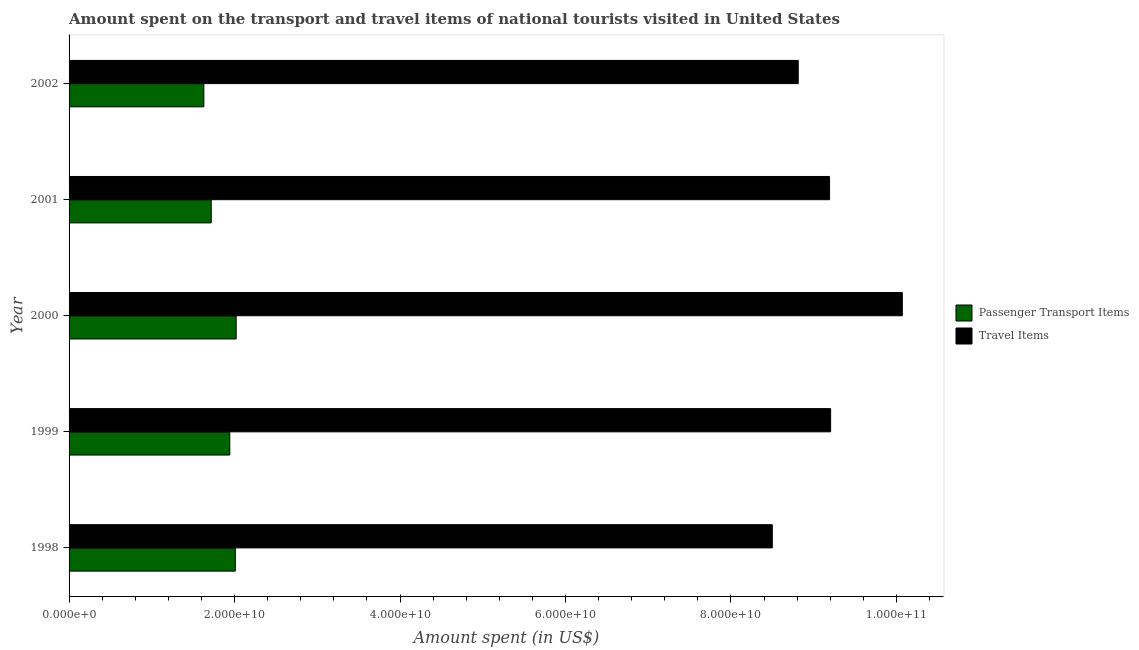How many bars are there on the 5th tick from the top?
Offer a terse response. 2. How many bars are there on the 3rd tick from the bottom?
Make the answer very short. 2. In how many cases, is the number of bars for a given year not equal to the number of legend labels?
Offer a very short reply. 0. What is the amount spent on passenger transport items in 2001?
Make the answer very short. 1.72e+1. Across all years, what is the maximum amount spent on passenger transport items?
Make the answer very short. 2.02e+1. Across all years, what is the minimum amount spent in travel items?
Ensure brevity in your answer.  8.50e+1. In which year was the amount spent in travel items minimum?
Offer a very short reply. 1998. What is the total amount spent on passenger transport items in the graph?
Your response must be concise. 9.32e+1. What is the difference between the amount spent on passenger transport items in 1999 and that in 2000?
Ensure brevity in your answer.  -7.71e+08. What is the difference between the amount spent in travel items in 2000 and the amount spent on passenger transport items in 2001?
Provide a succinct answer. 8.35e+1. What is the average amount spent in travel items per year?
Ensure brevity in your answer.  9.16e+1. In the year 2001, what is the difference between the amount spent in travel items and amount spent on passenger transport items?
Your response must be concise. 7.47e+1. In how many years, is the amount spent on passenger transport items greater than 64000000000 US$?
Your response must be concise. 0. What is the ratio of the amount spent on passenger transport items in 1998 to that in 2001?
Offer a very short reply. 1.17. What is the difference between the highest and the second highest amount spent in travel items?
Make the answer very short. 8.67e+09. What is the difference between the highest and the lowest amount spent in travel items?
Offer a terse response. 1.57e+1. Is the sum of the amount spent in travel items in 1998 and 1999 greater than the maximum amount spent on passenger transport items across all years?
Offer a terse response. Yes. What does the 1st bar from the top in 2000 represents?
Give a very brief answer. Travel Items. What does the 2nd bar from the bottom in 2001 represents?
Your answer should be very brief. Travel Items. Are all the bars in the graph horizontal?
Offer a terse response. Yes. Are the values on the major ticks of X-axis written in scientific E-notation?
Make the answer very short. Yes. Does the graph contain any zero values?
Keep it short and to the point. No. How many legend labels are there?
Ensure brevity in your answer.  2. What is the title of the graph?
Ensure brevity in your answer.  Amount spent on the transport and travel items of national tourists visited in United States. Does "Stunting" appear as one of the legend labels in the graph?
Your answer should be very brief. No. What is the label or title of the X-axis?
Ensure brevity in your answer.  Amount spent (in US$). What is the label or title of the Y-axis?
Ensure brevity in your answer.  Year. What is the Amount spent (in US$) in Passenger Transport Items in 1998?
Make the answer very short. 2.01e+1. What is the Amount spent (in US$) in Travel Items in 1998?
Make the answer very short. 8.50e+1. What is the Amount spent (in US$) of Passenger Transport Items in 1999?
Keep it short and to the point. 1.94e+1. What is the Amount spent (in US$) in Travel Items in 1999?
Provide a short and direct response. 9.20e+1. What is the Amount spent (in US$) of Passenger Transport Items in 2000?
Offer a terse response. 2.02e+1. What is the Amount spent (in US$) in Travel Items in 2000?
Keep it short and to the point. 1.01e+11. What is the Amount spent (in US$) in Passenger Transport Items in 2001?
Offer a terse response. 1.72e+1. What is the Amount spent (in US$) in Travel Items in 2001?
Give a very brief answer. 9.19e+1. What is the Amount spent (in US$) of Passenger Transport Items in 2002?
Your response must be concise. 1.63e+1. What is the Amount spent (in US$) in Travel Items in 2002?
Your answer should be compact. 8.81e+1. Across all years, what is the maximum Amount spent (in US$) of Passenger Transport Items?
Your response must be concise. 2.02e+1. Across all years, what is the maximum Amount spent (in US$) in Travel Items?
Make the answer very short. 1.01e+11. Across all years, what is the minimum Amount spent (in US$) of Passenger Transport Items?
Ensure brevity in your answer.  1.63e+1. Across all years, what is the minimum Amount spent (in US$) of Travel Items?
Keep it short and to the point. 8.50e+1. What is the total Amount spent (in US$) of Passenger Transport Items in the graph?
Your response must be concise. 9.32e+1. What is the total Amount spent (in US$) in Travel Items in the graph?
Your response must be concise. 4.58e+11. What is the difference between the Amount spent (in US$) of Passenger Transport Items in 1998 and that in 1999?
Make the answer very short. 6.69e+08. What is the difference between the Amount spent (in US$) of Travel Items in 1998 and that in 1999?
Keep it short and to the point. -7.05e+09. What is the difference between the Amount spent (in US$) in Passenger Transport Items in 1998 and that in 2000?
Give a very brief answer. -1.02e+08. What is the difference between the Amount spent (in US$) of Travel Items in 1998 and that in 2000?
Ensure brevity in your answer.  -1.57e+1. What is the difference between the Amount spent (in US$) of Passenger Transport Items in 1998 and that in 2001?
Your response must be concise. 2.91e+09. What is the difference between the Amount spent (in US$) in Travel Items in 1998 and that in 2001?
Provide a short and direct response. -6.92e+09. What is the difference between the Amount spent (in US$) of Passenger Transport Items in 1998 and that in 2002?
Offer a very short reply. 3.80e+09. What is the difference between the Amount spent (in US$) in Travel Items in 1998 and that in 2002?
Provide a short and direct response. -3.14e+09. What is the difference between the Amount spent (in US$) of Passenger Transport Items in 1999 and that in 2000?
Your response must be concise. -7.71e+08. What is the difference between the Amount spent (in US$) in Travel Items in 1999 and that in 2000?
Give a very brief answer. -8.67e+09. What is the difference between the Amount spent (in US$) in Passenger Transport Items in 1999 and that in 2001?
Keep it short and to the point. 2.24e+09. What is the difference between the Amount spent (in US$) of Travel Items in 1999 and that in 2001?
Provide a short and direct response. 1.28e+08. What is the difference between the Amount spent (in US$) in Passenger Transport Items in 1999 and that in 2002?
Offer a very short reply. 3.13e+09. What is the difference between the Amount spent (in US$) of Travel Items in 1999 and that in 2002?
Ensure brevity in your answer.  3.91e+09. What is the difference between the Amount spent (in US$) in Passenger Transport Items in 2000 and that in 2001?
Your answer should be very brief. 3.02e+09. What is the difference between the Amount spent (in US$) of Travel Items in 2000 and that in 2001?
Provide a short and direct response. 8.79e+09. What is the difference between the Amount spent (in US$) of Passenger Transport Items in 2000 and that in 2002?
Provide a succinct answer. 3.90e+09. What is the difference between the Amount spent (in US$) of Travel Items in 2000 and that in 2002?
Give a very brief answer. 1.26e+1. What is the difference between the Amount spent (in US$) in Passenger Transport Items in 2001 and that in 2002?
Ensure brevity in your answer.  8.90e+08. What is the difference between the Amount spent (in US$) of Travel Items in 2001 and that in 2002?
Keep it short and to the point. 3.79e+09. What is the difference between the Amount spent (in US$) of Passenger Transport Items in 1998 and the Amount spent (in US$) of Travel Items in 1999?
Offer a very short reply. -7.20e+1. What is the difference between the Amount spent (in US$) of Passenger Transport Items in 1998 and the Amount spent (in US$) of Travel Items in 2000?
Provide a succinct answer. -8.06e+1. What is the difference between the Amount spent (in US$) of Passenger Transport Items in 1998 and the Amount spent (in US$) of Travel Items in 2001?
Provide a short and direct response. -7.18e+1. What is the difference between the Amount spent (in US$) in Passenger Transport Items in 1998 and the Amount spent (in US$) in Travel Items in 2002?
Offer a very short reply. -6.80e+1. What is the difference between the Amount spent (in US$) of Passenger Transport Items in 1999 and the Amount spent (in US$) of Travel Items in 2000?
Provide a succinct answer. -8.13e+1. What is the difference between the Amount spent (in US$) of Passenger Transport Items in 1999 and the Amount spent (in US$) of Travel Items in 2001?
Make the answer very short. -7.25e+1. What is the difference between the Amount spent (in US$) of Passenger Transport Items in 1999 and the Amount spent (in US$) of Travel Items in 2002?
Keep it short and to the point. -6.87e+1. What is the difference between the Amount spent (in US$) of Passenger Transport Items in 2000 and the Amount spent (in US$) of Travel Items in 2001?
Ensure brevity in your answer.  -7.17e+1. What is the difference between the Amount spent (in US$) in Passenger Transport Items in 2000 and the Amount spent (in US$) in Travel Items in 2002?
Provide a short and direct response. -6.79e+1. What is the difference between the Amount spent (in US$) in Passenger Transport Items in 2001 and the Amount spent (in US$) in Travel Items in 2002?
Your response must be concise. -7.10e+1. What is the average Amount spent (in US$) in Passenger Transport Items per year?
Your answer should be very brief. 1.86e+1. What is the average Amount spent (in US$) in Travel Items per year?
Your response must be concise. 9.16e+1. In the year 1998, what is the difference between the Amount spent (in US$) in Passenger Transport Items and Amount spent (in US$) in Travel Items?
Provide a short and direct response. -6.49e+1. In the year 1999, what is the difference between the Amount spent (in US$) in Passenger Transport Items and Amount spent (in US$) in Travel Items?
Give a very brief answer. -7.26e+1. In the year 2000, what is the difference between the Amount spent (in US$) in Passenger Transport Items and Amount spent (in US$) in Travel Items?
Provide a short and direct response. -8.05e+1. In the year 2001, what is the difference between the Amount spent (in US$) in Passenger Transport Items and Amount spent (in US$) in Travel Items?
Offer a very short reply. -7.47e+1. In the year 2002, what is the difference between the Amount spent (in US$) of Passenger Transport Items and Amount spent (in US$) of Travel Items?
Ensure brevity in your answer.  -7.18e+1. What is the ratio of the Amount spent (in US$) in Passenger Transport Items in 1998 to that in 1999?
Give a very brief answer. 1.03. What is the ratio of the Amount spent (in US$) of Travel Items in 1998 to that in 1999?
Offer a terse response. 0.92. What is the ratio of the Amount spent (in US$) in Passenger Transport Items in 1998 to that in 2000?
Give a very brief answer. 0.99. What is the ratio of the Amount spent (in US$) of Travel Items in 1998 to that in 2000?
Your response must be concise. 0.84. What is the ratio of the Amount spent (in US$) of Passenger Transport Items in 1998 to that in 2001?
Give a very brief answer. 1.17. What is the ratio of the Amount spent (in US$) of Travel Items in 1998 to that in 2001?
Provide a succinct answer. 0.92. What is the ratio of the Amount spent (in US$) of Passenger Transport Items in 1998 to that in 2002?
Offer a terse response. 1.23. What is the ratio of the Amount spent (in US$) of Travel Items in 1998 to that in 2002?
Offer a terse response. 0.96. What is the ratio of the Amount spent (in US$) of Passenger Transport Items in 1999 to that in 2000?
Your answer should be compact. 0.96. What is the ratio of the Amount spent (in US$) in Travel Items in 1999 to that in 2000?
Give a very brief answer. 0.91. What is the ratio of the Amount spent (in US$) in Passenger Transport Items in 1999 to that in 2001?
Offer a terse response. 1.13. What is the ratio of the Amount spent (in US$) in Passenger Transport Items in 1999 to that in 2002?
Your answer should be very brief. 1.19. What is the ratio of the Amount spent (in US$) of Travel Items in 1999 to that in 2002?
Provide a short and direct response. 1.04. What is the ratio of the Amount spent (in US$) in Passenger Transport Items in 2000 to that in 2001?
Offer a very short reply. 1.18. What is the ratio of the Amount spent (in US$) in Travel Items in 2000 to that in 2001?
Your answer should be compact. 1.1. What is the ratio of the Amount spent (in US$) of Passenger Transport Items in 2000 to that in 2002?
Your response must be concise. 1.24. What is the ratio of the Amount spent (in US$) of Travel Items in 2000 to that in 2002?
Your answer should be very brief. 1.14. What is the ratio of the Amount spent (in US$) of Passenger Transport Items in 2001 to that in 2002?
Provide a succinct answer. 1.05. What is the ratio of the Amount spent (in US$) of Travel Items in 2001 to that in 2002?
Make the answer very short. 1.04. What is the difference between the highest and the second highest Amount spent (in US$) in Passenger Transport Items?
Your answer should be compact. 1.02e+08. What is the difference between the highest and the second highest Amount spent (in US$) of Travel Items?
Provide a succinct answer. 8.67e+09. What is the difference between the highest and the lowest Amount spent (in US$) of Passenger Transport Items?
Give a very brief answer. 3.90e+09. What is the difference between the highest and the lowest Amount spent (in US$) in Travel Items?
Your answer should be compact. 1.57e+1. 